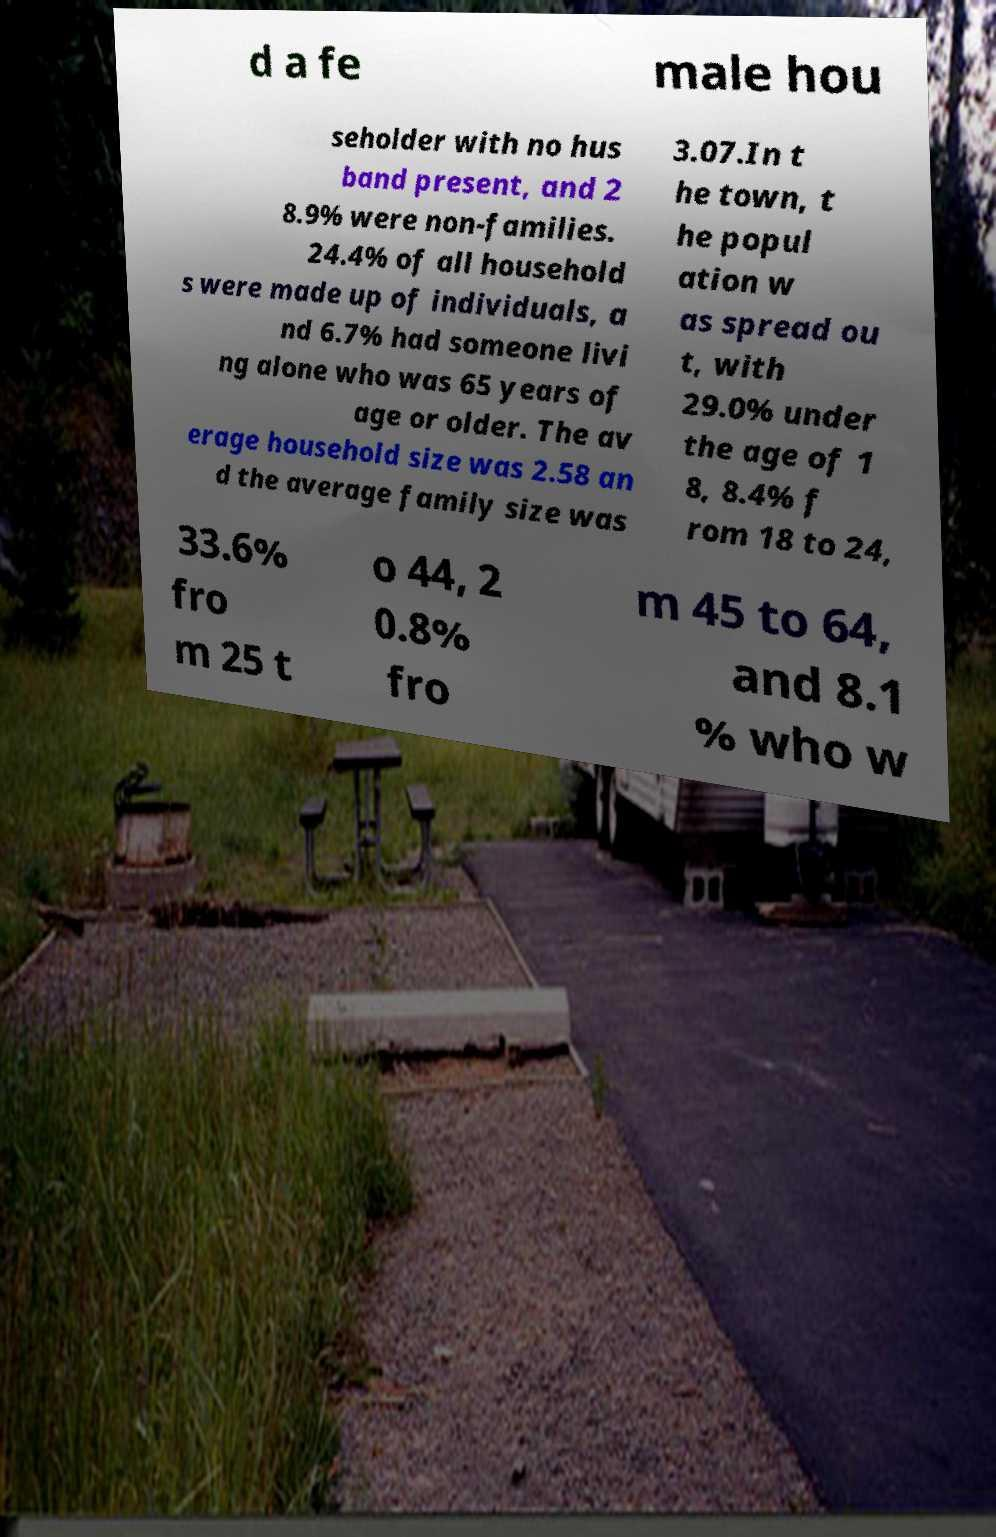Please read and relay the text visible in this image. What does it say? d a fe male hou seholder with no hus band present, and 2 8.9% were non-families. 24.4% of all household s were made up of individuals, a nd 6.7% had someone livi ng alone who was 65 years of age or older. The av erage household size was 2.58 an d the average family size was 3.07.In t he town, t he popul ation w as spread ou t, with 29.0% under the age of 1 8, 8.4% f rom 18 to 24, 33.6% fro m 25 t o 44, 2 0.8% fro m 45 to 64, and 8.1 % who w 